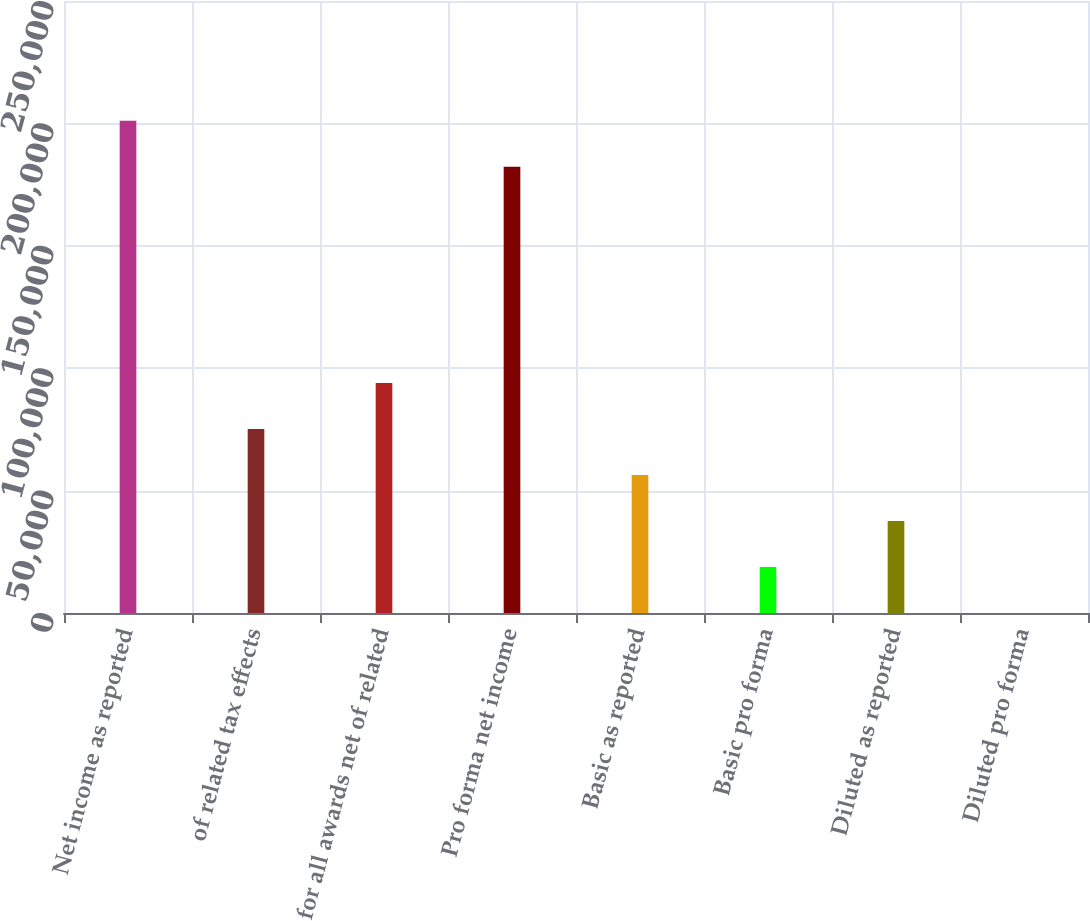Convert chart to OTSL. <chart><loc_0><loc_0><loc_500><loc_500><bar_chart><fcel>Net income as reported<fcel>of related tax effects<fcel>for all awards net of related<fcel>Pro forma net income<fcel>Basic as reported<fcel>Basic pro forma<fcel>Diluted as reported<fcel>Diluted pro forma<nl><fcel>201114<fcel>75196.2<fcel>93994.8<fcel>182315<fcel>56397.5<fcel>18800.2<fcel>37598.9<fcel>1.61<nl></chart> 